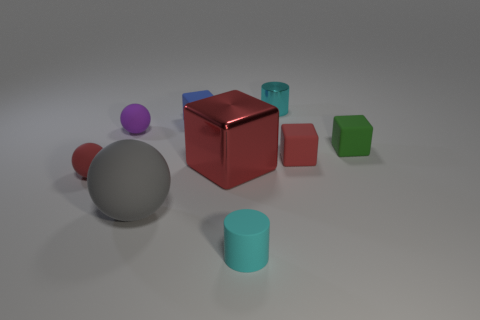Add 1 small blue matte objects. How many objects exist? 10 Subtract 2 cylinders. How many cylinders are left? 0 Subtract all small purple rubber spheres. How many spheres are left? 2 Subtract all small red things. Subtract all cyan cylinders. How many objects are left? 5 Add 9 red metal objects. How many red metal objects are left? 10 Add 1 big blue balls. How many big blue balls exist? 1 Subtract all green cubes. How many cubes are left? 3 Subtract 0 green cylinders. How many objects are left? 9 Subtract all blocks. How many objects are left? 5 Subtract all cyan cubes. Subtract all red cylinders. How many cubes are left? 4 